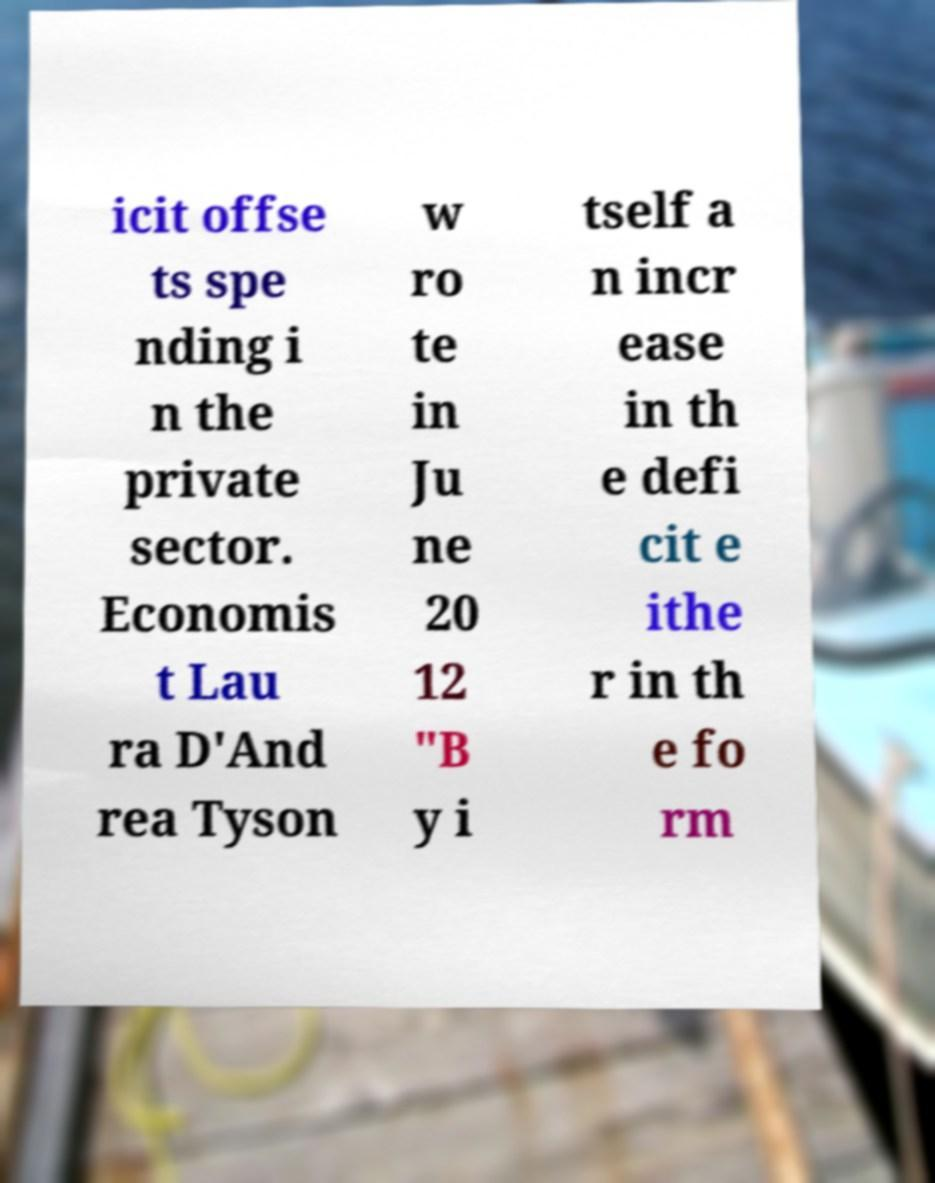For documentation purposes, I need the text within this image transcribed. Could you provide that? icit offse ts spe nding i n the private sector. Economis t Lau ra D'And rea Tyson w ro te in Ju ne 20 12 "B y i tself a n incr ease in th e defi cit e ithe r in th e fo rm 